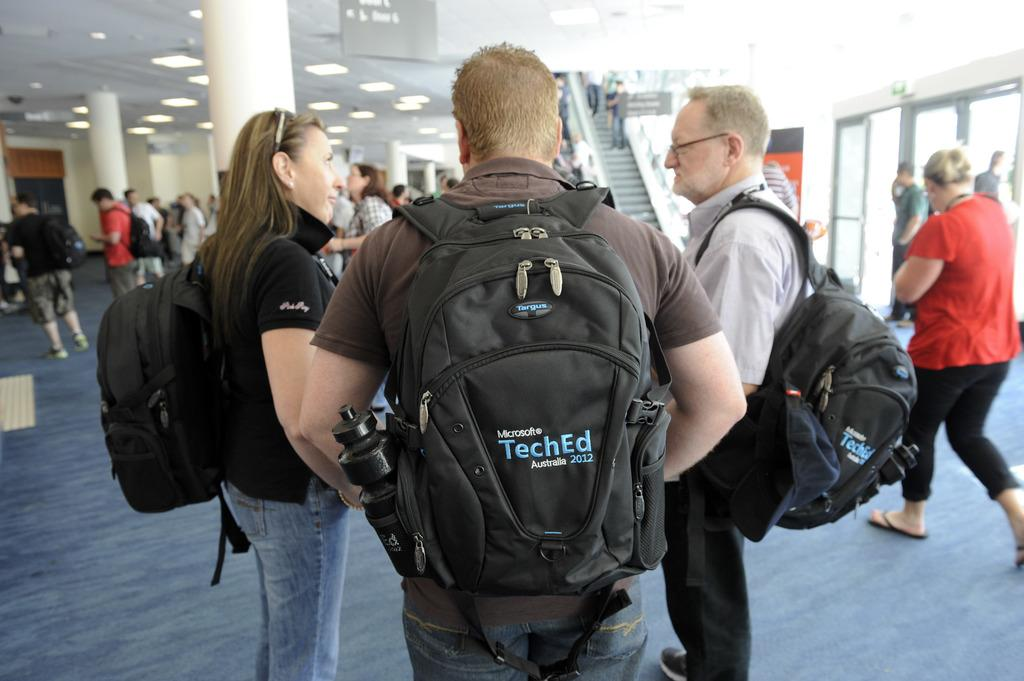<image>
Present a compact description of the photo's key features. A man is walking through a crowded area with a backpack that says Microsoft TechEd Australia 2012 on it. 